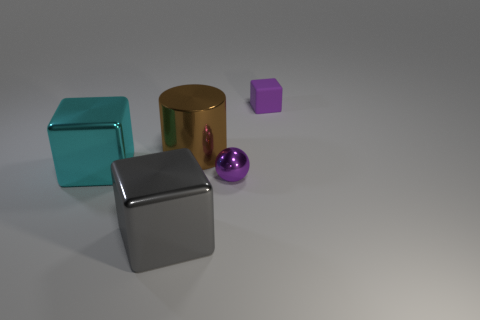What textures are present among the objects in this image? In the image, there are objects that exhibit different textures. The turquoise and the grey cubes have a matte texture, while the gold cylinder and the purple object appear to have metallic textures. The small sphere has a shiny, reflective surface. 